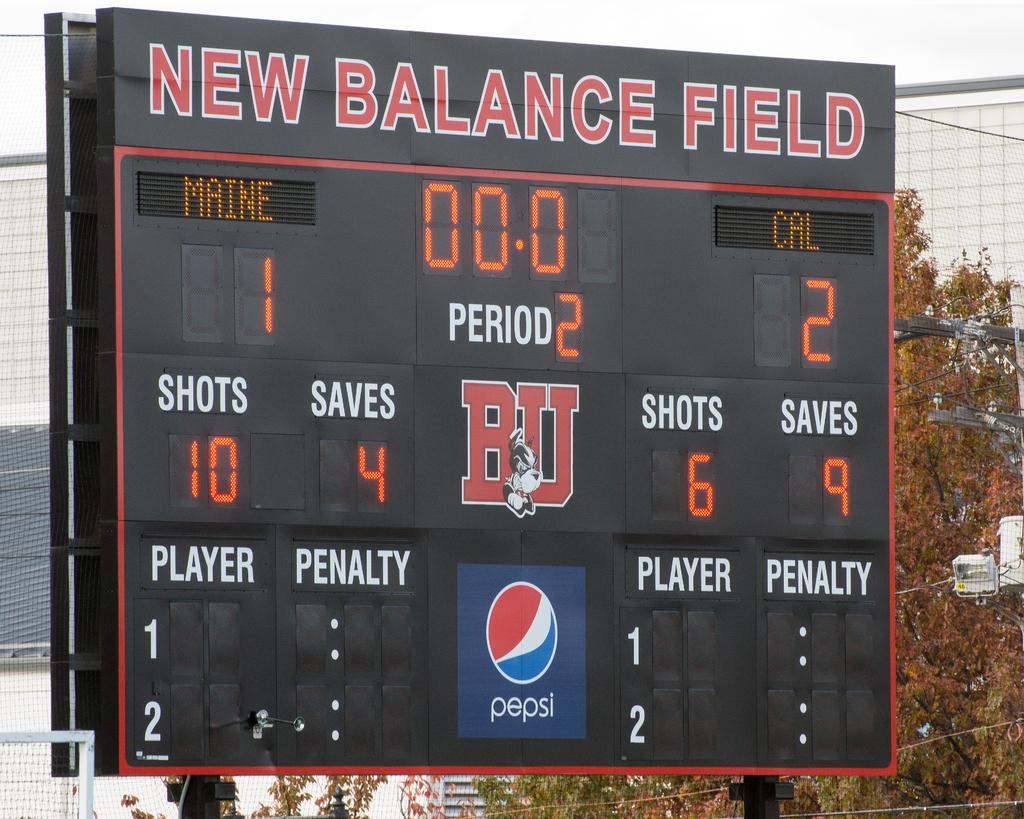<image>
Render a clear and concise summary of the photo. A large scoreboard is labeled New Balance Field. 